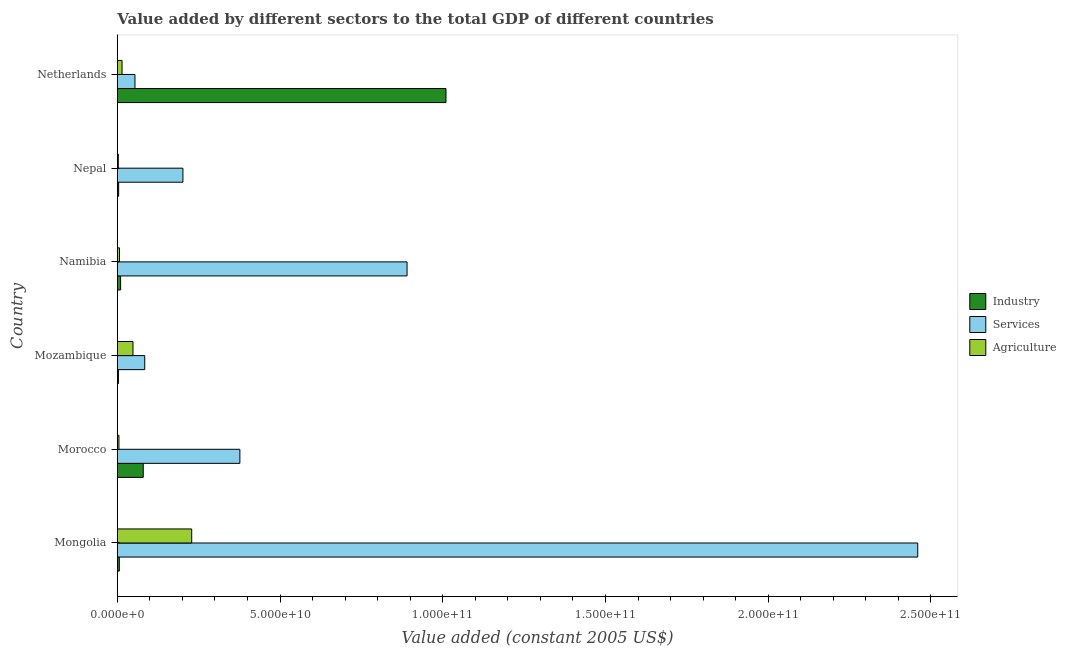How many different coloured bars are there?
Your answer should be very brief. 3. How many groups of bars are there?
Provide a succinct answer. 6. Are the number of bars per tick equal to the number of legend labels?
Ensure brevity in your answer.  Yes. How many bars are there on the 1st tick from the bottom?
Your response must be concise. 3. What is the label of the 3rd group of bars from the top?
Offer a terse response. Namibia. What is the value added by industrial sector in Nepal?
Make the answer very short. 4.21e+08. Across all countries, what is the maximum value added by agricultural sector?
Keep it short and to the point. 2.29e+1. Across all countries, what is the minimum value added by industrial sector?
Make the answer very short. 3.53e+08. In which country was the value added by industrial sector maximum?
Your answer should be very brief. Netherlands. In which country was the value added by agricultural sector minimum?
Your answer should be compact. Nepal. What is the total value added by services in the graph?
Keep it short and to the point. 4.07e+11. What is the difference between the value added by services in Namibia and that in Netherlands?
Keep it short and to the point. 8.36e+1. What is the difference between the value added by services in Netherlands and the value added by industrial sector in Namibia?
Ensure brevity in your answer.  4.42e+09. What is the average value added by services per country?
Keep it short and to the point. 6.78e+1. What is the difference between the value added by services and value added by industrial sector in Nepal?
Provide a short and direct response. 1.97e+1. What is the ratio of the value added by agricultural sector in Morocco to that in Namibia?
Provide a short and direct response. 0.75. Is the value added by agricultural sector in Mozambique less than that in Netherlands?
Offer a terse response. No. What is the difference between the highest and the second highest value added by agricultural sector?
Keep it short and to the point. 1.80e+1. What is the difference between the highest and the lowest value added by agricultural sector?
Offer a terse response. 2.25e+1. In how many countries, is the value added by agricultural sector greater than the average value added by agricultural sector taken over all countries?
Your answer should be very brief. 1. What does the 3rd bar from the top in Netherlands represents?
Offer a terse response. Industry. What does the 1st bar from the bottom in Netherlands represents?
Give a very brief answer. Industry. Is it the case that in every country, the sum of the value added by industrial sector and value added by services is greater than the value added by agricultural sector?
Offer a terse response. Yes. How many bars are there?
Provide a short and direct response. 18. How many countries are there in the graph?
Give a very brief answer. 6. What is the difference between two consecutive major ticks on the X-axis?
Give a very brief answer. 5.00e+1. Are the values on the major ticks of X-axis written in scientific E-notation?
Your response must be concise. Yes. Does the graph contain any zero values?
Ensure brevity in your answer.  No. Does the graph contain grids?
Give a very brief answer. No. Where does the legend appear in the graph?
Offer a terse response. Center right. How many legend labels are there?
Keep it short and to the point. 3. What is the title of the graph?
Offer a terse response. Value added by different sectors to the total GDP of different countries. Does "Ireland" appear as one of the legend labels in the graph?
Provide a short and direct response. No. What is the label or title of the X-axis?
Your response must be concise. Value added (constant 2005 US$). What is the Value added (constant 2005 US$) in Industry in Mongolia?
Give a very brief answer. 6.26e+08. What is the Value added (constant 2005 US$) in Services in Mongolia?
Offer a very short reply. 2.46e+11. What is the Value added (constant 2005 US$) in Agriculture in Mongolia?
Ensure brevity in your answer.  2.29e+1. What is the Value added (constant 2005 US$) in Industry in Morocco?
Your response must be concise. 7.98e+09. What is the Value added (constant 2005 US$) in Services in Morocco?
Keep it short and to the point. 3.77e+1. What is the Value added (constant 2005 US$) in Agriculture in Morocco?
Give a very brief answer. 5.06e+08. What is the Value added (constant 2005 US$) of Industry in Mozambique?
Your answer should be compact. 3.53e+08. What is the Value added (constant 2005 US$) of Services in Mozambique?
Your response must be concise. 8.43e+09. What is the Value added (constant 2005 US$) of Agriculture in Mozambique?
Offer a very short reply. 4.83e+09. What is the Value added (constant 2005 US$) of Industry in Namibia?
Give a very brief answer. 1.02e+09. What is the Value added (constant 2005 US$) of Services in Namibia?
Offer a terse response. 8.90e+1. What is the Value added (constant 2005 US$) in Agriculture in Namibia?
Offer a terse response. 6.78e+08. What is the Value added (constant 2005 US$) in Industry in Nepal?
Make the answer very short. 4.21e+08. What is the Value added (constant 2005 US$) in Services in Nepal?
Your response must be concise. 2.02e+1. What is the Value added (constant 2005 US$) of Agriculture in Nepal?
Make the answer very short. 3.16e+08. What is the Value added (constant 2005 US$) in Industry in Netherlands?
Ensure brevity in your answer.  1.01e+11. What is the Value added (constant 2005 US$) in Services in Netherlands?
Provide a short and direct response. 5.44e+09. What is the Value added (constant 2005 US$) of Agriculture in Netherlands?
Give a very brief answer. 1.47e+09. Across all countries, what is the maximum Value added (constant 2005 US$) of Industry?
Your answer should be compact. 1.01e+11. Across all countries, what is the maximum Value added (constant 2005 US$) in Services?
Keep it short and to the point. 2.46e+11. Across all countries, what is the maximum Value added (constant 2005 US$) in Agriculture?
Your response must be concise. 2.29e+1. Across all countries, what is the minimum Value added (constant 2005 US$) of Industry?
Your response must be concise. 3.53e+08. Across all countries, what is the minimum Value added (constant 2005 US$) of Services?
Provide a short and direct response. 5.44e+09. Across all countries, what is the minimum Value added (constant 2005 US$) in Agriculture?
Provide a succinct answer. 3.16e+08. What is the total Value added (constant 2005 US$) of Industry in the graph?
Ensure brevity in your answer.  1.11e+11. What is the total Value added (constant 2005 US$) in Services in the graph?
Provide a succinct answer. 4.07e+11. What is the total Value added (constant 2005 US$) of Agriculture in the graph?
Ensure brevity in your answer.  3.07e+1. What is the difference between the Value added (constant 2005 US$) of Industry in Mongolia and that in Morocco?
Offer a terse response. -7.35e+09. What is the difference between the Value added (constant 2005 US$) in Services in Mongolia and that in Morocco?
Your answer should be very brief. 2.08e+11. What is the difference between the Value added (constant 2005 US$) in Agriculture in Mongolia and that in Morocco?
Make the answer very short. 2.24e+1. What is the difference between the Value added (constant 2005 US$) of Industry in Mongolia and that in Mozambique?
Offer a very short reply. 2.73e+08. What is the difference between the Value added (constant 2005 US$) in Services in Mongolia and that in Mozambique?
Your answer should be compact. 2.38e+11. What is the difference between the Value added (constant 2005 US$) of Agriculture in Mongolia and that in Mozambique?
Your answer should be compact. 1.80e+1. What is the difference between the Value added (constant 2005 US$) of Industry in Mongolia and that in Namibia?
Give a very brief answer. -3.95e+08. What is the difference between the Value added (constant 2005 US$) of Services in Mongolia and that in Namibia?
Make the answer very short. 1.57e+11. What is the difference between the Value added (constant 2005 US$) of Agriculture in Mongolia and that in Namibia?
Make the answer very short. 2.22e+1. What is the difference between the Value added (constant 2005 US$) of Industry in Mongolia and that in Nepal?
Your answer should be very brief. 2.05e+08. What is the difference between the Value added (constant 2005 US$) of Services in Mongolia and that in Nepal?
Offer a terse response. 2.26e+11. What is the difference between the Value added (constant 2005 US$) in Agriculture in Mongolia and that in Nepal?
Provide a succinct answer. 2.25e+1. What is the difference between the Value added (constant 2005 US$) of Industry in Mongolia and that in Netherlands?
Ensure brevity in your answer.  -1.00e+11. What is the difference between the Value added (constant 2005 US$) in Services in Mongolia and that in Netherlands?
Keep it short and to the point. 2.41e+11. What is the difference between the Value added (constant 2005 US$) in Agriculture in Mongolia and that in Netherlands?
Make the answer very short. 2.14e+1. What is the difference between the Value added (constant 2005 US$) of Industry in Morocco and that in Mozambique?
Your answer should be very brief. 7.62e+09. What is the difference between the Value added (constant 2005 US$) in Services in Morocco and that in Mozambique?
Keep it short and to the point. 2.92e+1. What is the difference between the Value added (constant 2005 US$) in Agriculture in Morocco and that in Mozambique?
Offer a very short reply. -4.32e+09. What is the difference between the Value added (constant 2005 US$) in Industry in Morocco and that in Namibia?
Ensure brevity in your answer.  6.96e+09. What is the difference between the Value added (constant 2005 US$) in Services in Morocco and that in Namibia?
Give a very brief answer. -5.14e+1. What is the difference between the Value added (constant 2005 US$) in Agriculture in Morocco and that in Namibia?
Give a very brief answer. -1.71e+08. What is the difference between the Value added (constant 2005 US$) of Industry in Morocco and that in Nepal?
Offer a terse response. 7.56e+09. What is the difference between the Value added (constant 2005 US$) of Services in Morocco and that in Nepal?
Make the answer very short. 1.75e+1. What is the difference between the Value added (constant 2005 US$) of Agriculture in Morocco and that in Nepal?
Provide a short and direct response. 1.91e+08. What is the difference between the Value added (constant 2005 US$) in Industry in Morocco and that in Netherlands?
Keep it short and to the point. -9.30e+1. What is the difference between the Value added (constant 2005 US$) of Services in Morocco and that in Netherlands?
Give a very brief answer. 3.22e+1. What is the difference between the Value added (constant 2005 US$) of Agriculture in Morocco and that in Netherlands?
Provide a succinct answer. -9.59e+08. What is the difference between the Value added (constant 2005 US$) of Industry in Mozambique and that in Namibia?
Offer a terse response. -6.68e+08. What is the difference between the Value added (constant 2005 US$) of Services in Mozambique and that in Namibia?
Your response must be concise. -8.06e+1. What is the difference between the Value added (constant 2005 US$) of Agriculture in Mozambique and that in Namibia?
Give a very brief answer. 4.15e+09. What is the difference between the Value added (constant 2005 US$) of Industry in Mozambique and that in Nepal?
Offer a very short reply. -6.82e+07. What is the difference between the Value added (constant 2005 US$) in Services in Mozambique and that in Nepal?
Offer a terse response. -1.17e+1. What is the difference between the Value added (constant 2005 US$) in Agriculture in Mozambique and that in Nepal?
Your answer should be compact. 4.51e+09. What is the difference between the Value added (constant 2005 US$) in Industry in Mozambique and that in Netherlands?
Offer a terse response. -1.01e+11. What is the difference between the Value added (constant 2005 US$) in Services in Mozambique and that in Netherlands?
Ensure brevity in your answer.  3.00e+09. What is the difference between the Value added (constant 2005 US$) of Agriculture in Mozambique and that in Netherlands?
Keep it short and to the point. 3.36e+09. What is the difference between the Value added (constant 2005 US$) of Industry in Namibia and that in Nepal?
Your answer should be compact. 6.00e+08. What is the difference between the Value added (constant 2005 US$) in Services in Namibia and that in Nepal?
Give a very brief answer. 6.89e+1. What is the difference between the Value added (constant 2005 US$) of Agriculture in Namibia and that in Nepal?
Keep it short and to the point. 3.62e+08. What is the difference between the Value added (constant 2005 US$) of Industry in Namibia and that in Netherlands?
Give a very brief answer. -1.00e+11. What is the difference between the Value added (constant 2005 US$) of Services in Namibia and that in Netherlands?
Provide a short and direct response. 8.36e+1. What is the difference between the Value added (constant 2005 US$) in Agriculture in Namibia and that in Netherlands?
Provide a short and direct response. -7.88e+08. What is the difference between the Value added (constant 2005 US$) in Industry in Nepal and that in Netherlands?
Make the answer very short. -1.01e+11. What is the difference between the Value added (constant 2005 US$) of Services in Nepal and that in Netherlands?
Provide a succinct answer. 1.47e+1. What is the difference between the Value added (constant 2005 US$) of Agriculture in Nepal and that in Netherlands?
Provide a succinct answer. -1.15e+09. What is the difference between the Value added (constant 2005 US$) of Industry in Mongolia and the Value added (constant 2005 US$) of Services in Morocco?
Ensure brevity in your answer.  -3.70e+1. What is the difference between the Value added (constant 2005 US$) in Industry in Mongolia and the Value added (constant 2005 US$) in Agriculture in Morocco?
Make the answer very short. 1.19e+08. What is the difference between the Value added (constant 2005 US$) of Services in Mongolia and the Value added (constant 2005 US$) of Agriculture in Morocco?
Provide a short and direct response. 2.45e+11. What is the difference between the Value added (constant 2005 US$) in Industry in Mongolia and the Value added (constant 2005 US$) in Services in Mozambique?
Offer a very short reply. -7.81e+09. What is the difference between the Value added (constant 2005 US$) in Industry in Mongolia and the Value added (constant 2005 US$) in Agriculture in Mozambique?
Your answer should be very brief. -4.20e+09. What is the difference between the Value added (constant 2005 US$) of Services in Mongolia and the Value added (constant 2005 US$) of Agriculture in Mozambique?
Your response must be concise. 2.41e+11. What is the difference between the Value added (constant 2005 US$) in Industry in Mongolia and the Value added (constant 2005 US$) in Services in Namibia?
Make the answer very short. -8.84e+1. What is the difference between the Value added (constant 2005 US$) in Industry in Mongolia and the Value added (constant 2005 US$) in Agriculture in Namibia?
Make the answer very short. -5.18e+07. What is the difference between the Value added (constant 2005 US$) in Services in Mongolia and the Value added (constant 2005 US$) in Agriculture in Namibia?
Offer a terse response. 2.45e+11. What is the difference between the Value added (constant 2005 US$) in Industry in Mongolia and the Value added (constant 2005 US$) in Services in Nepal?
Offer a very short reply. -1.95e+1. What is the difference between the Value added (constant 2005 US$) of Industry in Mongolia and the Value added (constant 2005 US$) of Agriculture in Nepal?
Provide a succinct answer. 3.10e+08. What is the difference between the Value added (constant 2005 US$) in Services in Mongolia and the Value added (constant 2005 US$) in Agriculture in Nepal?
Provide a succinct answer. 2.46e+11. What is the difference between the Value added (constant 2005 US$) in Industry in Mongolia and the Value added (constant 2005 US$) in Services in Netherlands?
Keep it short and to the point. -4.81e+09. What is the difference between the Value added (constant 2005 US$) of Industry in Mongolia and the Value added (constant 2005 US$) of Agriculture in Netherlands?
Keep it short and to the point. -8.40e+08. What is the difference between the Value added (constant 2005 US$) in Services in Mongolia and the Value added (constant 2005 US$) in Agriculture in Netherlands?
Offer a very short reply. 2.44e+11. What is the difference between the Value added (constant 2005 US$) of Industry in Morocco and the Value added (constant 2005 US$) of Services in Mozambique?
Your response must be concise. -4.57e+08. What is the difference between the Value added (constant 2005 US$) in Industry in Morocco and the Value added (constant 2005 US$) in Agriculture in Mozambique?
Offer a terse response. 3.15e+09. What is the difference between the Value added (constant 2005 US$) of Services in Morocco and the Value added (constant 2005 US$) of Agriculture in Mozambique?
Offer a terse response. 3.28e+1. What is the difference between the Value added (constant 2005 US$) in Industry in Morocco and the Value added (constant 2005 US$) in Services in Namibia?
Your response must be concise. -8.11e+1. What is the difference between the Value added (constant 2005 US$) of Industry in Morocco and the Value added (constant 2005 US$) of Agriculture in Namibia?
Offer a very short reply. 7.30e+09. What is the difference between the Value added (constant 2005 US$) of Services in Morocco and the Value added (constant 2005 US$) of Agriculture in Namibia?
Offer a very short reply. 3.70e+1. What is the difference between the Value added (constant 2005 US$) in Industry in Morocco and the Value added (constant 2005 US$) in Services in Nepal?
Your answer should be compact. -1.22e+1. What is the difference between the Value added (constant 2005 US$) in Industry in Morocco and the Value added (constant 2005 US$) in Agriculture in Nepal?
Your answer should be compact. 7.66e+09. What is the difference between the Value added (constant 2005 US$) in Services in Morocco and the Value added (constant 2005 US$) in Agriculture in Nepal?
Provide a succinct answer. 3.73e+1. What is the difference between the Value added (constant 2005 US$) of Industry in Morocco and the Value added (constant 2005 US$) of Services in Netherlands?
Keep it short and to the point. 2.54e+09. What is the difference between the Value added (constant 2005 US$) of Industry in Morocco and the Value added (constant 2005 US$) of Agriculture in Netherlands?
Make the answer very short. 6.51e+09. What is the difference between the Value added (constant 2005 US$) of Services in Morocco and the Value added (constant 2005 US$) of Agriculture in Netherlands?
Give a very brief answer. 3.62e+1. What is the difference between the Value added (constant 2005 US$) of Industry in Mozambique and the Value added (constant 2005 US$) of Services in Namibia?
Offer a very short reply. -8.87e+1. What is the difference between the Value added (constant 2005 US$) of Industry in Mozambique and the Value added (constant 2005 US$) of Agriculture in Namibia?
Provide a short and direct response. -3.25e+08. What is the difference between the Value added (constant 2005 US$) of Services in Mozambique and the Value added (constant 2005 US$) of Agriculture in Namibia?
Ensure brevity in your answer.  7.76e+09. What is the difference between the Value added (constant 2005 US$) in Industry in Mozambique and the Value added (constant 2005 US$) in Services in Nepal?
Make the answer very short. -1.98e+1. What is the difference between the Value added (constant 2005 US$) in Industry in Mozambique and the Value added (constant 2005 US$) in Agriculture in Nepal?
Offer a very short reply. 3.70e+07. What is the difference between the Value added (constant 2005 US$) in Services in Mozambique and the Value added (constant 2005 US$) in Agriculture in Nepal?
Offer a terse response. 8.12e+09. What is the difference between the Value added (constant 2005 US$) of Industry in Mozambique and the Value added (constant 2005 US$) of Services in Netherlands?
Keep it short and to the point. -5.08e+09. What is the difference between the Value added (constant 2005 US$) in Industry in Mozambique and the Value added (constant 2005 US$) in Agriculture in Netherlands?
Offer a very short reply. -1.11e+09. What is the difference between the Value added (constant 2005 US$) in Services in Mozambique and the Value added (constant 2005 US$) in Agriculture in Netherlands?
Your answer should be compact. 6.97e+09. What is the difference between the Value added (constant 2005 US$) in Industry in Namibia and the Value added (constant 2005 US$) in Services in Nepal?
Your response must be concise. -1.91e+1. What is the difference between the Value added (constant 2005 US$) of Industry in Namibia and the Value added (constant 2005 US$) of Agriculture in Nepal?
Ensure brevity in your answer.  7.05e+08. What is the difference between the Value added (constant 2005 US$) in Services in Namibia and the Value added (constant 2005 US$) in Agriculture in Nepal?
Give a very brief answer. 8.87e+1. What is the difference between the Value added (constant 2005 US$) in Industry in Namibia and the Value added (constant 2005 US$) in Services in Netherlands?
Your answer should be very brief. -4.42e+09. What is the difference between the Value added (constant 2005 US$) of Industry in Namibia and the Value added (constant 2005 US$) of Agriculture in Netherlands?
Offer a very short reply. -4.45e+08. What is the difference between the Value added (constant 2005 US$) of Services in Namibia and the Value added (constant 2005 US$) of Agriculture in Netherlands?
Your answer should be very brief. 8.76e+1. What is the difference between the Value added (constant 2005 US$) in Industry in Nepal and the Value added (constant 2005 US$) in Services in Netherlands?
Your answer should be compact. -5.02e+09. What is the difference between the Value added (constant 2005 US$) in Industry in Nepal and the Value added (constant 2005 US$) in Agriculture in Netherlands?
Offer a very short reply. -1.04e+09. What is the difference between the Value added (constant 2005 US$) of Services in Nepal and the Value added (constant 2005 US$) of Agriculture in Netherlands?
Ensure brevity in your answer.  1.87e+1. What is the average Value added (constant 2005 US$) of Industry per country?
Keep it short and to the point. 1.86e+1. What is the average Value added (constant 2005 US$) of Services per country?
Offer a very short reply. 6.78e+1. What is the average Value added (constant 2005 US$) of Agriculture per country?
Your response must be concise. 5.11e+09. What is the difference between the Value added (constant 2005 US$) of Industry and Value added (constant 2005 US$) of Services in Mongolia?
Give a very brief answer. -2.45e+11. What is the difference between the Value added (constant 2005 US$) in Industry and Value added (constant 2005 US$) in Agriculture in Mongolia?
Your answer should be compact. -2.22e+1. What is the difference between the Value added (constant 2005 US$) in Services and Value added (constant 2005 US$) in Agriculture in Mongolia?
Your response must be concise. 2.23e+11. What is the difference between the Value added (constant 2005 US$) in Industry and Value added (constant 2005 US$) in Services in Morocco?
Ensure brevity in your answer.  -2.97e+1. What is the difference between the Value added (constant 2005 US$) in Industry and Value added (constant 2005 US$) in Agriculture in Morocco?
Provide a succinct answer. 7.47e+09. What is the difference between the Value added (constant 2005 US$) in Services and Value added (constant 2005 US$) in Agriculture in Morocco?
Offer a very short reply. 3.72e+1. What is the difference between the Value added (constant 2005 US$) of Industry and Value added (constant 2005 US$) of Services in Mozambique?
Provide a short and direct response. -8.08e+09. What is the difference between the Value added (constant 2005 US$) of Industry and Value added (constant 2005 US$) of Agriculture in Mozambique?
Your response must be concise. -4.47e+09. What is the difference between the Value added (constant 2005 US$) of Services and Value added (constant 2005 US$) of Agriculture in Mozambique?
Make the answer very short. 3.61e+09. What is the difference between the Value added (constant 2005 US$) in Industry and Value added (constant 2005 US$) in Services in Namibia?
Keep it short and to the point. -8.80e+1. What is the difference between the Value added (constant 2005 US$) of Industry and Value added (constant 2005 US$) of Agriculture in Namibia?
Your answer should be compact. 3.43e+08. What is the difference between the Value added (constant 2005 US$) of Services and Value added (constant 2005 US$) of Agriculture in Namibia?
Make the answer very short. 8.84e+1. What is the difference between the Value added (constant 2005 US$) of Industry and Value added (constant 2005 US$) of Services in Nepal?
Provide a succinct answer. -1.97e+1. What is the difference between the Value added (constant 2005 US$) in Industry and Value added (constant 2005 US$) in Agriculture in Nepal?
Provide a succinct answer. 1.05e+08. What is the difference between the Value added (constant 2005 US$) of Services and Value added (constant 2005 US$) of Agriculture in Nepal?
Your answer should be very brief. 1.99e+1. What is the difference between the Value added (constant 2005 US$) of Industry and Value added (constant 2005 US$) of Services in Netherlands?
Provide a short and direct response. 9.56e+1. What is the difference between the Value added (constant 2005 US$) in Industry and Value added (constant 2005 US$) in Agriculture in Netherlands?
Your response must be concise. 9.95e+1. What is the difference between the Value added (constant 2005 US$) of Services and Value added (constant 2005 US$) of Agriculture in Netherlands?
Provide a succinct answer. 3.97e+09. What is the ratio of the Value added (constant 2005 US$) of Industry in Mongolia to that in Morocco?
Keep it short and to the point. 0.08. What is the ratio of the Value added (constant 2005 US$) of Services in Mongolia to that in Morocco?
Your response must be concise. 6.53. What is the ratio of the Value added (constant 2005 US$) of Agriculture in Mongolia to that in Morocco?
Give a very brief answer. 45.15. What is the ratio of the Value added (constant 2005 US$) in Industry in Mongolia to that in Mozambique?
Your answer should be very brief. 1.77. What is the ratio of the Value added (constant 2005 US$) of Services in Mongolia to that in Mozambique?
Your answer should be compact. 29.16. What is the ratio of the Value added (constant 2005 US$) of Agriculture in Mongolia to that in Mozambique?
Offer a very short reply. 4.74. What is the ratio of the Value added (constant 2005 US$) in Industry in Mongolia to that in Namibia?
Offer a terse response. 0.61. What is the ratio of the Value added (constant 2005 US$) of Services in Mongolia to that in Namibia?
Keep it short and to the point. 2.76. What is the ratio of the Value added (constant 2005 US$) in Agriculture in Mongolia to that in Namibia?
Ensure brevity in your answer.  33.74. What is the ratio of the Value added (constant 2005 US$) in Industry in Mongolia to that in Nepal?
Your answer should be compact. 1.49. What is the ratio of the Value added (constant 2005 US$) of Services in Mongolia to that in Nepal?
Your response must be concise. 12.2. What is the ratio of the Value added (constant 2005 US$) in Agriculture in Mongolia to that in Nepal?
Your answer should be compact. 72.42. What is the ratio of the Value added (constant 2005 US$) in Industry in Mongolia to that in Netherlands?
Give a very brief answer. 0.01. What is the ratio of the Value added (constant 2005 US$) in Services in Mongolia to that in Netherlands?
Provide a short and direct response. 45.24. What is the ratio of the Value added (constant 2005 US$) in Agriculture in Mongolia to that in Netherlands?
Offer a very short reply. 15.6. What is the ratio of the Value added (constant 2005 US$) in Industry in Morocco to that in Mozambique?
Make the answer very short. 22.62. What is the ratio of the Value added (constant 2005 US$) of Services in Morocco to that in Mozambique?
Keep it short and to the point. 4.47. What is the ratio of the Value added (constant 2005 US$) in Agriculture in Morocco to that in Mozambique?
Offer a very short reply. 0.1. What is the ratio of the Value added (constant 2005 US$) in Industry in Morocco to that in Namibia?
Keep it short and to the point. 7.81. What is the ratio of the Value added (constant 2005 US$) of Services in Morocco to that in Namibia?
Offer a terse response. 0.42. What is the ratio of the Value added (constant 2005 US$) of Agriculture in Morocco to that in Namibia?
Offer a very short reply. 0.75. What is the ratio of the Value added (constant 2005 US$) in Industry in Morocco to that in Nepal?
Offer a terse response. 18.95. What is the ratio of the Value added (constant 2005 US$) of Services in Morocco to that in Nepal?
Offer a very short reply. 1.87. What is the ratio of the Value added (constant 2005 US$) of Agriculture in Morocco to that in Nepal?
Offer a very short reply. 1.6. What is the ratio of the Value added (constant 2005 US$) of Industry in Morocco to that in Netherlands?
Your answer should be compact. 0.08. What is the ratio of the Value added (constant 2005 US$) in Services in Morocco to that in Netherlands?
Offer a very short reply. 6.93. What is the ratio of the Value added (constant 2005 US$) of Agriculture in Morocco to that in Netherlands?
Offer a very short reply. 0.35. What is the ratio of the Value added (constant 2005 US$) of Industry in Mozambique to that in Namibia?
Give a very brief answer. 0.35. What is the ratio of the Value added (constant 2005 US$) in Services in Mozambique to that in Namibia?
Your answer should be very brief. 0.09. What is the ratio of the Value added (constant 2005 US$) in Agriculture in Mozambique to that in Namibia?
Provide a succinct answer. 7.12. What is the ratio of the Value added (constant 2005 US$) of Industry in Mozambique to that in Nepal?
Ensure brevity in your answer.  0.84. What is the ratio of the Value added (constant 2005 US$) of Services in Mozambique to that in Nepal?
Offer a terse response. 0.42. What is the ratio of the Value added (constant 2005 US$) in Agriculture in Mozambique to that in Nepal?
Offer a very short reply. 15.29. What is the ratio of the Value added (constant 2005 US$) of Industry in Mozambique to that in Netherlands?
Keep it short and to the point. 0. What is the ratio of the Value added (constant 2005 US$) of Services in Mozambique to that in Netherlands?
Ensure brevity in your answer.  1.55. What is the ratio of the Value added (constant 2005 US$) in Agriculture in Mozambique to that in Netherlands?
Offer a very short reply. 3.29. What is the ratio of the Value added (constant 2005 US$) of Industry in Namibia to that in Nepal?
Your answer should be compact. 2.43. What is the ratio of the Value added (constant 2005 US$) of Services in Namibia to that in Nepal?
Offer a very short reply. 4.41. What is the ratio of the Value added (constant 2005 US$) of Agriculture in Namibia to that in Nepal?
Your answer should be very brief. 2.15. What is the ratio of the Value added (constant 2005 US$) of Industry in Namibia to that in Netherlands?
Keep it short and to the point. 0.01. What is the ratio of the Value added (constant 2005 US$) in Services in Namibia to that in Netherlands?
Offer a very short reply. 16.38. What is the ratio of the Value added (constant 2005 US$) in Agriculture in Namibia to that in Netherlands?
Your answer should be compact. 0.46. What is the ratio of the Value added (constant 2005 US$) of Industry in Nepal to that in Netherlands?
Ensure brevity in your answer.  0. What is the ratio of the Value added (constant 2005 US$) of Services in Nepal to that in Netherlands?
Ensure brevity in your answer.  3.71. What is the ratio of the Value added (constant 2005 US$) of Agriculture in Nepal to that in Netherlands?
Offer a terse response. 0.22. What is the difference between the highest and the second highest Value added (constant 2005 US$) of Industry?
Give a very brief answer. 9.30e+1. What is the difference between the highest and the second highest Value added (constant 2005 US$) of Services?
Ensure brevity in your answer.  1.57e+11. What is the difference between the highest and the second highest Value added (constant 2005 US$) in Agriculture?
Your response must be concise. 1.80e+1. What is the difference between the highest and the lowest Value added (constant 2005 US$) of Industry?
Ensure brevity in your answer.  1.01e+11. What is the difference between the highest and the lowest Value added (constant 2005 US$) of Services?
Your answer should be very brief. 2.41e+11. What is the difference between the highest and the lowest Value added (constant 2005 US$) of Agriculture?
Provide a short and direct response. 2.25e+1. 